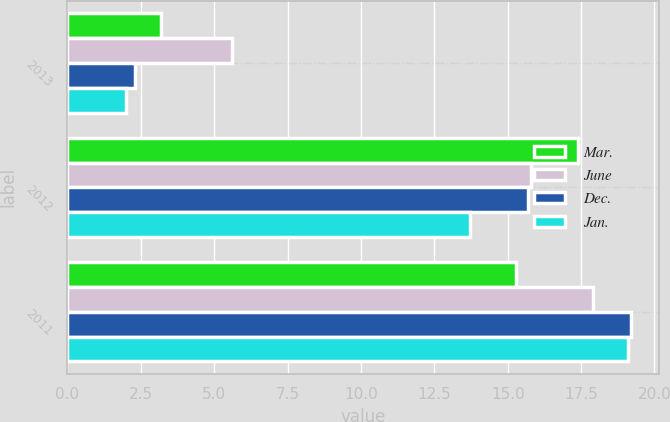Convert chart. <chart><loc_0><loc_0><loc_500><loc_500><stacked_bar_chart><ecel><fcel>2013<fcel>2012<fcel>2011<nl><fcel>Mar.<fcel>3.2<fcel>17.4<fcel>15.3<nl><fcel>June<fcel>5.6<fcel>15.8<fcel>17.9<nl><fcel>Dec.<fcel>2.3<fcel>15.7<fcel>19.2<nl><fcel>Jan.<fcel>2<fcel>13.7<fcel>19.1<nl></chart> 